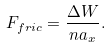<formula> <loc_0><loc_0><loc_500><loc_500>F _ { f r i c } = \frac { \Delta W } { n a _ { x } } .</formula> 